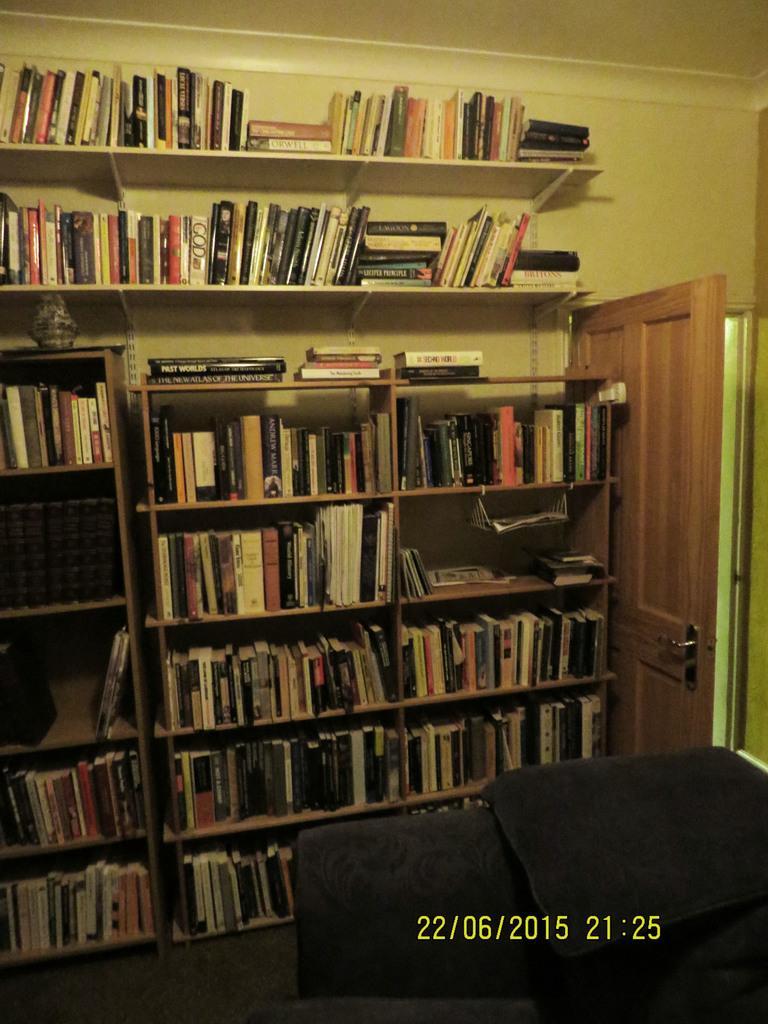Can you describe this image briefly? In this picture, we can see racks and in the racks there are different kinds of books and on the right side of the racks there is a wooden door and a wall. On the image there is a watermark. 